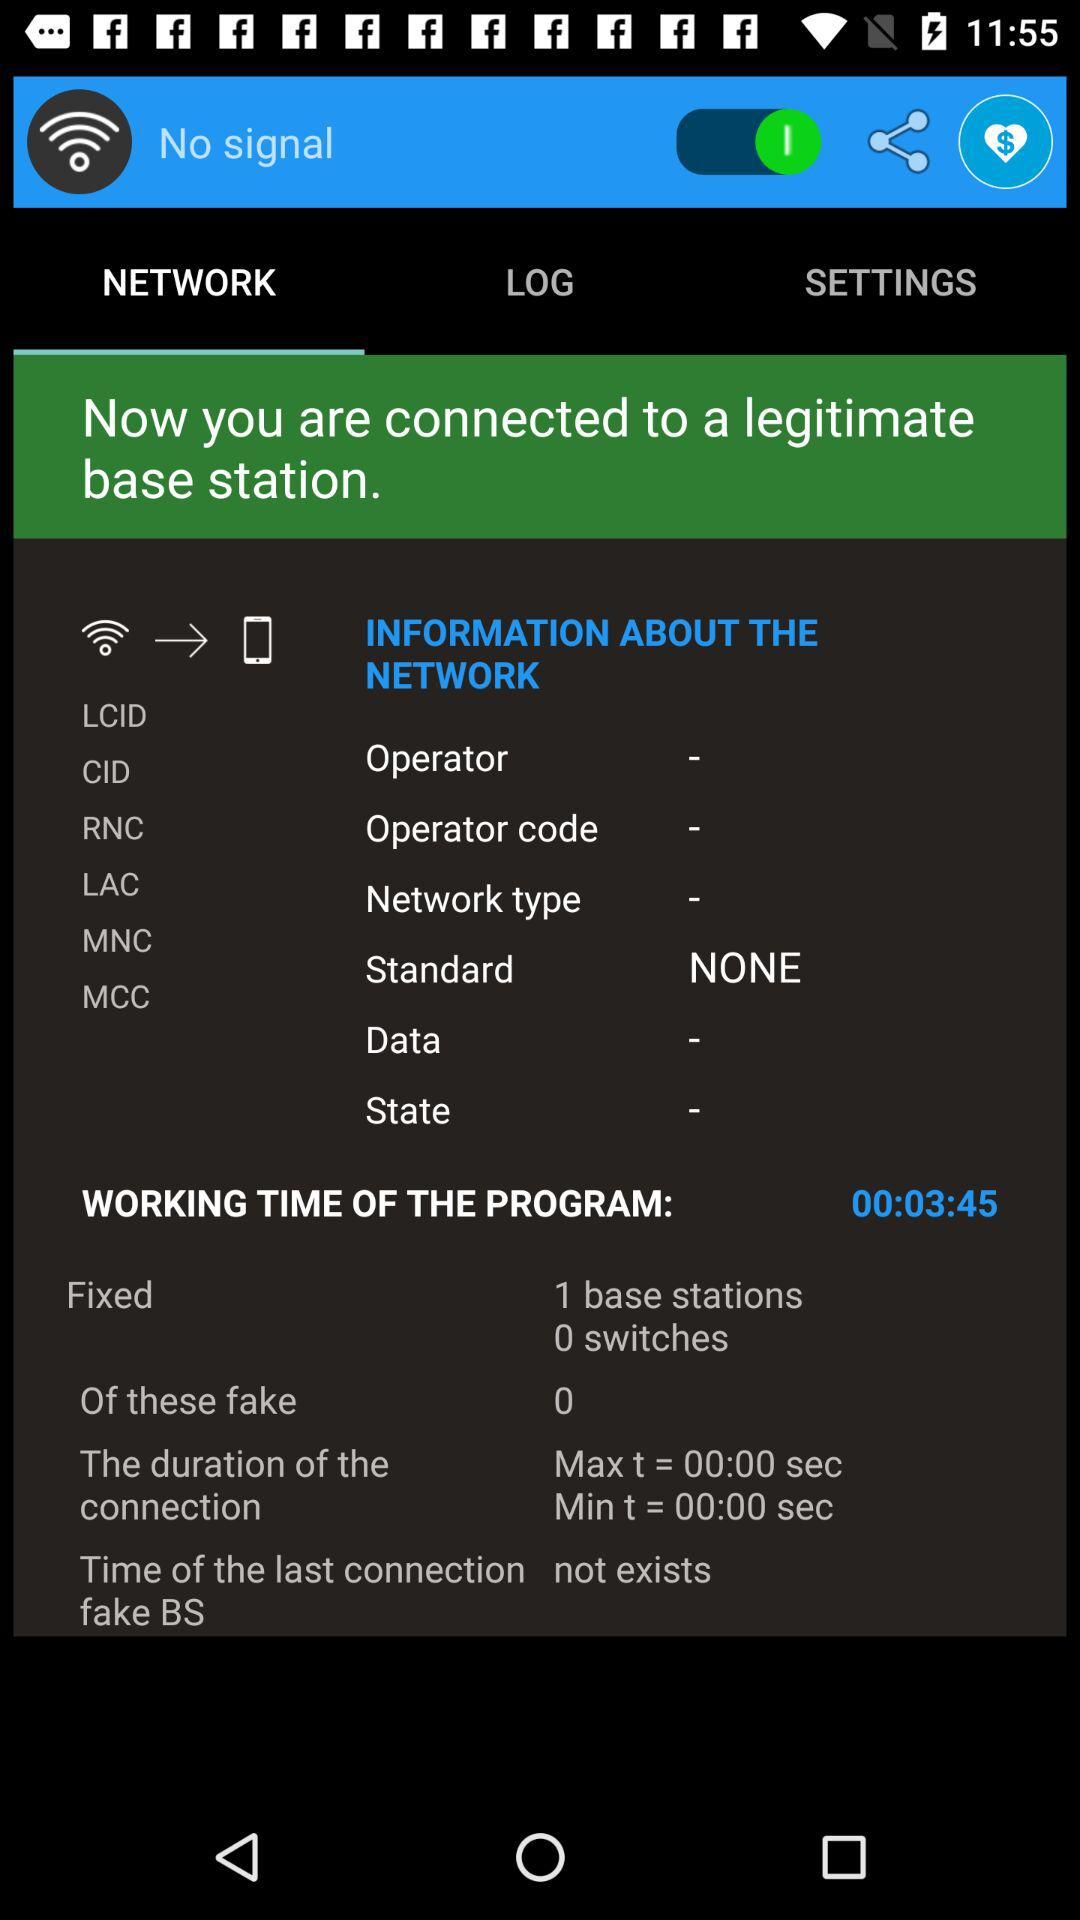How is the signal right now? There is no signal right now. 